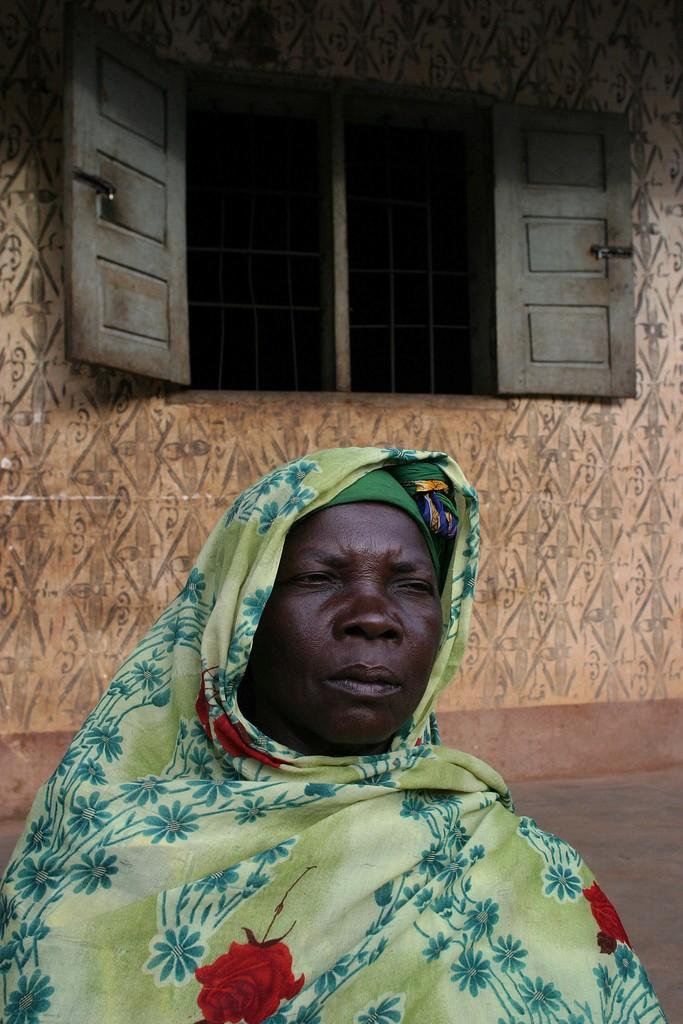Who is the main subject in the image? There is a woman in the center of the image. What can be seen in the background of the image? There is a wall and a window in the background of the image. What type of throne is the woman sitting on in the image? There is no throne present in the image; the woman is standing. 